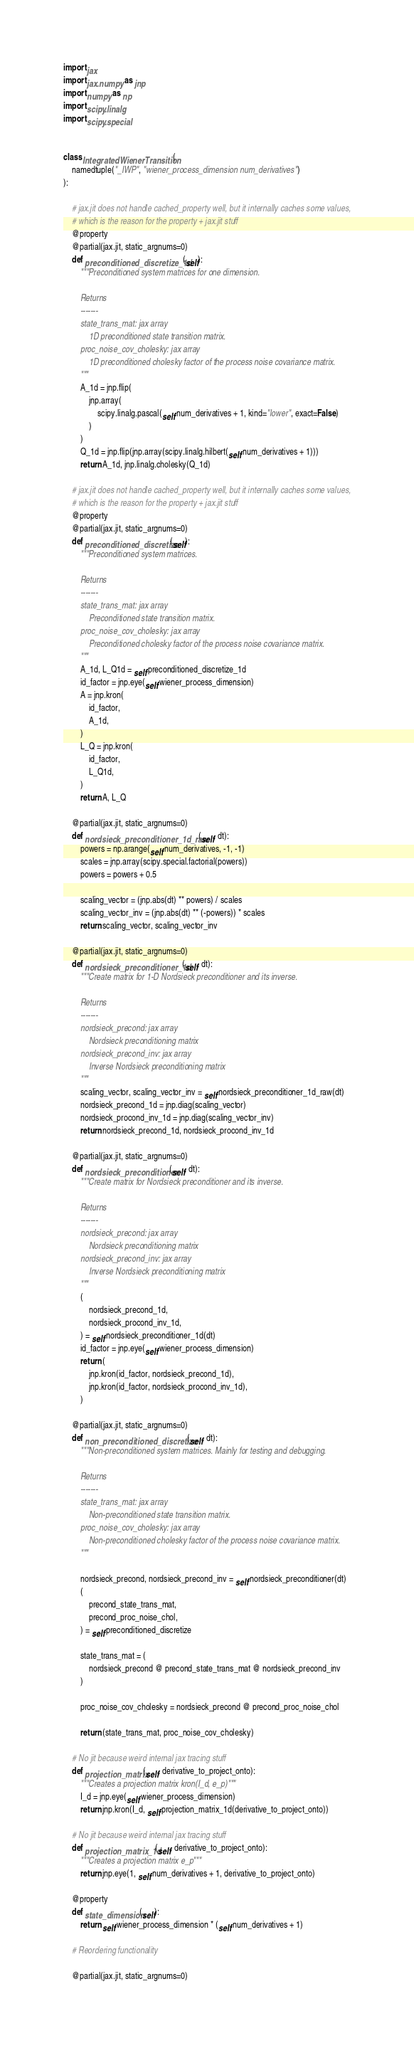Convert code to text. <code><loc_0><loc_0><loc_500><loc_500><_Python_>import jax
import jax.numpy as jnp
import numpy as np
import scipy.linalg
import scipy.special


class IntegratedWienerTransition(
    namedtuple("_IWP", "wiener_process_dimension num_derivatives")
):

    # jax.jit does not handle cached_property well, but it internally caches some values,
    # which is the reason for the property + jax.jit stuff
    @property
    @partial(jax.jit, static_argnums=0)
    def preconditioned_discretize_1d(self):
        """Preconditioned system matrices for one dimension.

        Returns
        -------
        state_trans_mat: jax array
            1D preconditioned state transition matrix.
        proc_noise_cov_cholesky: jax array
            1D preconditioned cholesky factor of the process noise covariance matrix.
        """
        A_1d = jnp.flip(
            jnp.array(
                scipy.linalg.pascal(self.num_derivatives + 1, kind="lower", exact=False)
            )
        )
        Q_1d = jnp.flip(jnp.array(scipy.linalg.hilbert(self.num_derivatives + 1)))
        return A_1d, jnp.linalg.cholesky(Q_1d)

    # jax.jit does not handle cached_property well, but it internally caches some values,
    # which is the reason for the property + jax.jit stuff
    @property
    @partial(jax.jit, static_argnums=0)
    def preconditioned_discretize(self):
        """Preconditioned system matrices.

        Returns
        -------
        state_trans_mat: jax array
            Preconditioned state transition matrix.
        proc_noise_cov_cholesky: jax array
            Preconditioned cholesky factor of the process noise covariance matrix.
        """
        A_1d, L_Q1d = self.preconditioned_discretize_1d
        id_factor = jnp.eye(self.wiener_process_dimension)
        A = jnp.kron(
            id_factor,
            A_1d,
        )
        L_Q = jnp.kron(
            id_factor,
            L_Q1d,
        )
        return A, L_Q

    @partial(jax.jit, static_argnums=0)
    def nordsieck_preconditioner_1d_raw(self, dt):
        powers = np.arange(self.num_derivatives, -1, -1)
        scales = jnp.array(scipy.special.factorial(powers))
        powers = powers + 0.5

        scaling_vector = (jnp.abs(dt) ** powers) / scales
        scaling_vector_inv = (jnp.abs(dt) ** (-powers)) * scales
        return scaling_vector, scaling_vector_inv

    @partial(jax.jit, static_argnums=0)
    def nordsieck_preconditioner_1d(self, dt):
        """Create matrix for 1-D Nordsieck preconditioner and its inverse.

        Returns
        -------
        nordsieck_precond: jax array
            Nordsieck preconditioning matrix
        nordsieck_precond_inv: jax array
            Inverse Nordsieck preconditioning matrix
        """
        scaling_vector, scaling_vector_inv = self.nordsieck_preconditioner_1d_raw(dt)
        nordsieck_precond_1d = jnp.diag(scaling_vector)
        nordsieck_procond_inv_1d = jnp.diag(scaling_vector_inv)
        return nordsieck_precond_1d, nordsieck_procond_inv_1d

    @partial(jax.jit, static_argnums=0)
    def nordsieck_preconditioner(self, dt):
        """Create matrix for Nordsieck preconditioner and its inverse.

        Returns
        -------
        nordsieck_precond: jax array
            Nordsieck preconditioning matrix
        nordsieck_precond_inv: jax array
            Inverse Nordsieck preconditioning matrix
        """
        (
            nordsieck_precond_1d,
            nordsieck_procond_inv_1d,
        ) = self.nordsieck_preconditioner_1d(dt)
        id_factor = jnp.eye(self.wiener_process_dimension)
        return (
            jnp.kron(id_factor, nordsieck_precond_1d),
            jnp.kron(id_factor, nordsieck_procond_inv_1d),
        )

    @partial(jax.jit, static_argnums=0)
    def non_preconditioned_discretize(self, dt):
        """Non-preconditioned system matrices. Mainly for testing and debugging.

        Returns
        -------
        state_trans_mat: jax array
            Non-preconditioned state transition matrix.
        proc_noise_cov_cholesky: jax array
            Non-preconditioned cholesky factor of the process noise covariance matrix.
        """

        nordsieck_precond, nordsieck_precond_inv = self.nordsieck_preconditioner(dt)
        (
            precond_state_trans_mat,
            precond_proc_noise_chol,
        ) = self.preconditioned_discretize

        state_trans_mat = (
            nordsieck_precond @ precond_state_trans_mat @ nordsieck_precond_inv
        )

        proc_noise_cov_cholesky = nordsieck_precond @ precond_proc_noise_chol

        return (state_trans_mat, proc_noise_cov_cholesky)

    # No jit because weird internal jax tracing stuff
    def projection_matrix(self, derivative_to_project_onto):
        """Creates a projection matrix kron(I_d, e_p)"""
        I_d = jnp.eye(self.wiener_process_dimension)
        return jnp.kron(I_d, self.projection_matrix_1d(derivative_to_project_onto))

    # No jit because weird internal jax tracing stuff
    def projection_matrix_1d(self, derivative_to_project_onto):
        """Creates a projection matrix e_p"""
        return jnp.eye(1, self.num_derivatives + 1, derivative_to_project_onto)

    @property
    def state_dimension(self):
        return self.wiener_process_dimension * (self.num_derivatives + 1)

    # Reordering functionality

    @partial(jax.jit, static_argnums=0)</code> 